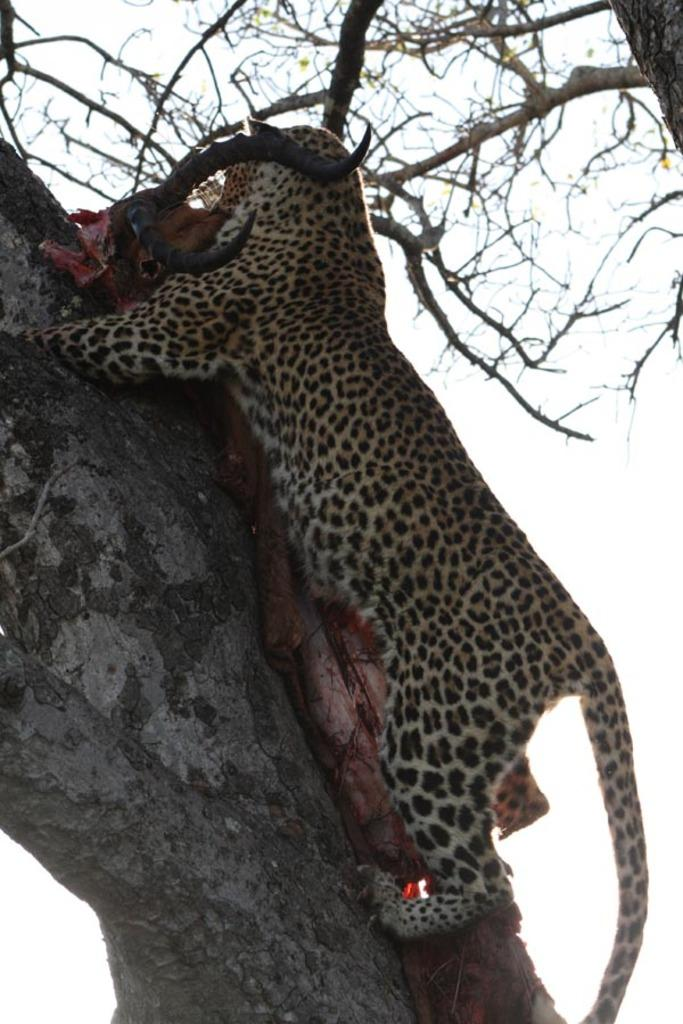What type of plant can be seen in the image? There is a tree in the image. What part of the natural environment is visible in the image? The sky is visible in the image. What type of animal is present in the image? There is a cheetah in the image. What type of dust can be seen on the board in the image? There is no board or dust present in the image; it features a tree, sky, and a cheetah. 